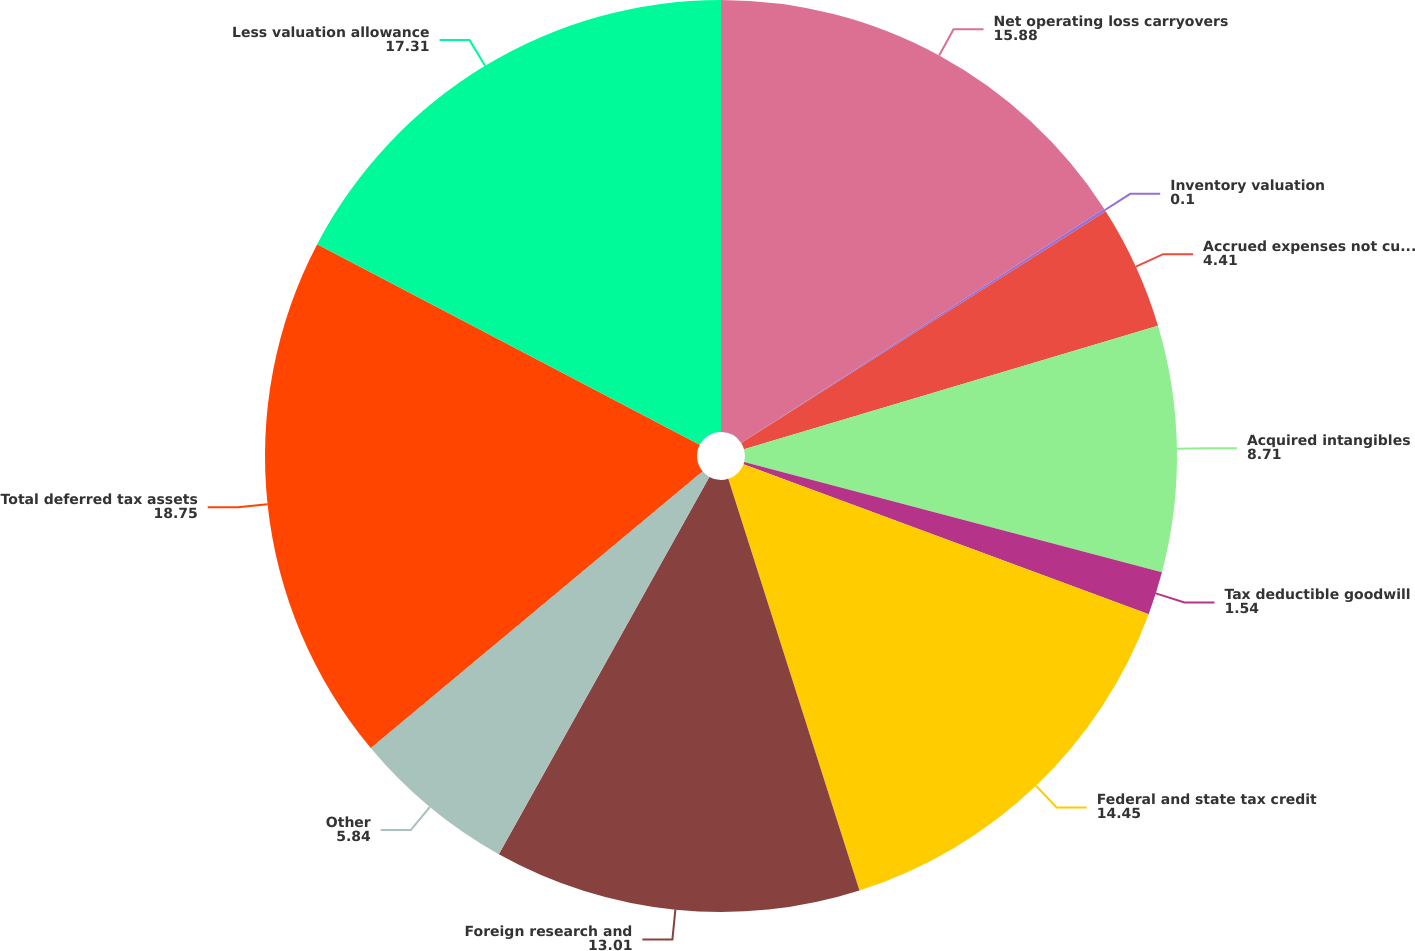Convert chart. <chart><loc_0><loc_0><loc_500><loc_500><pie_chart><fcel>Net operating loss carryovers<fcel>Inventory valuation<fcel>Accrued expenses not currently<fcel>Acquired intangibles<fcel>Tax deductible goodwill<fcel>Federal and state tax credit<fcel>Foreign research and<fcel>Other<fcel>Total deferred tax assets<fcel>Less valuation allowance<nl><fcel>15.88%<fcel>0.1%<fcel>4.41%<fcel>8.71%<fcel>1.54%<fcel>14.45%<fcel>13.01%<fcel>5.84%<fcel>18.75%<fcel>17.31%<nl></chart> 